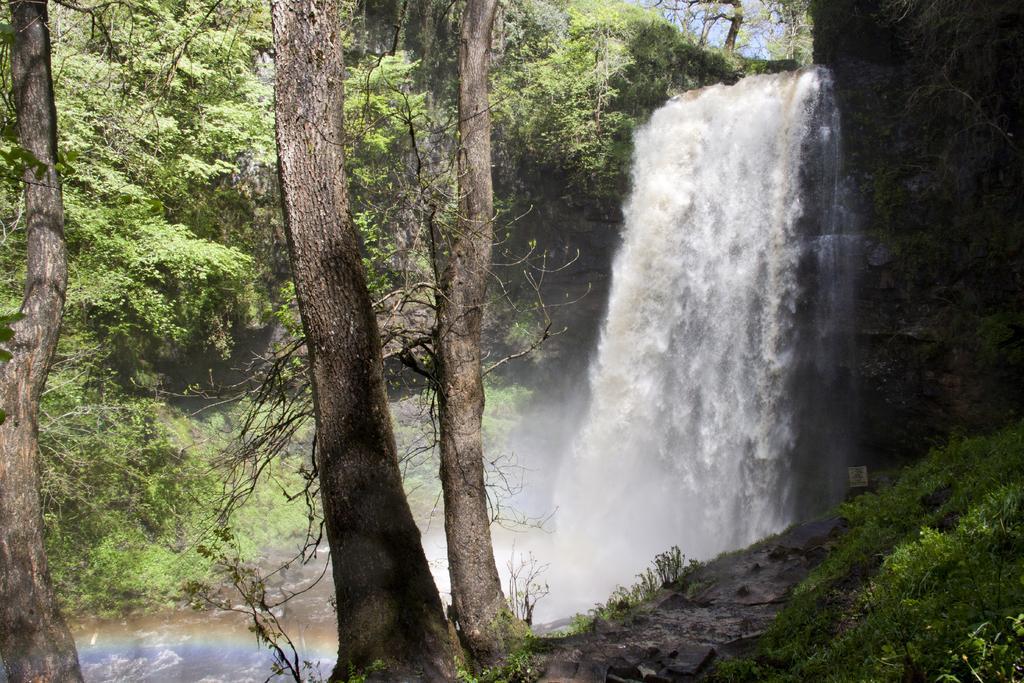Could you give a brief overview of what you see in this image? In the picture there is a beautiful waterfall and around the waterfall there are many trees. 